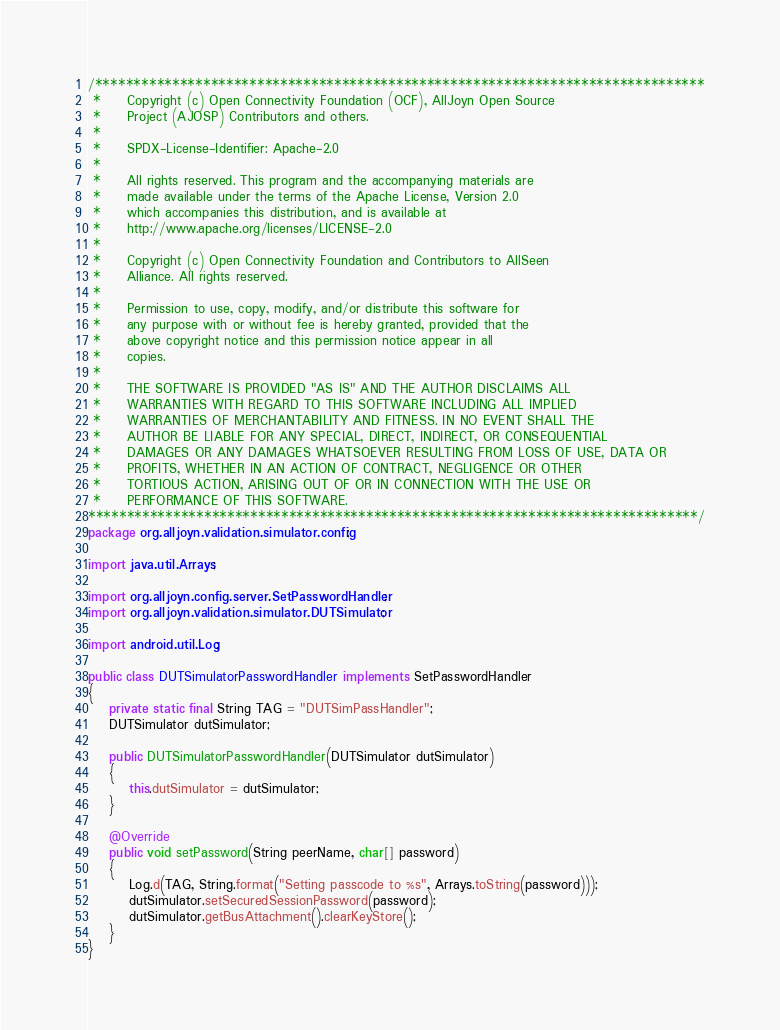Convert code to text. <code><loc_0><loc_0><loc_500><loc_500><_Java_>/*******************************************************************************
 *     Copyright (c) Open Connectivity Foundation (OCF), AllJoyn Open Source
 *     Project (AJOSP) Contributors and others.
 *     
 *     SPDX-License-Identifier: Apache-2.0
 *     
 *     All rights reserved. This program and the accompanying materials are
 *     made available under the terms of the Apache License, Version 2.0
 *     which accompanies this distribution, and is available at
 *     http://www.apache.org/licenses/LICENSE-2.0
 *     
 *     Copyright (c) Open Connectivity Foundation and Contributors to AllSeen
 *     Alliance. All rights reserved.
 *     
 *     Permission to use, copy, modify, and/or distribute this software for
 *     any purpose with or without fee is hereby granted, provided that the
 *     above copyright notice and this permission notice appear in all
 *     copies.
 *     
 *     THE SOFTWARE IS PROVIDED "AS IS" AND THE AUTHOR DISCLAIMS ALL
 *     WARRANTIES WITH REGARD TO THIS SOFTWARE INCLUDING ALL IMPLIED
 *     WARRANTIES OF MERCHANTABILITY AND FITNESS. IN NO EVENT SHALL THE
 *     AUTHOR BE LIABLE FOR ANY SPECIAL, DIRECT, INDIRECT, OR CONSEQUENTIAL
 *     DAMAGES OR ANY DAMAGES WHATSOEVER RESULTING FROM LOSS OF USE, DATA OR
 *     PROFITS, WHETHER IN AN ACTION OF CONTRACT, NEGLIGENCE OR OTHER
 *     TORTIOUS ACTION, ARISING OUT OF OR IN CONNECTION WITH THE USE OR
 *     PERFORMANCE OF THIS SOFTWARE.
*******************************************************************************/
package org.alljoyn.validation.simulator.config;

import java.util.Arrays;

import org.alljoyn.config.server.SetPasswordHandler;
import org.alljoyn.validation.simulator.DUTSimulator;

import android.util.Log;

public class DUTSimulatorPasswordHandler implements SetPasswordHandler
{
    private static final String TAG = "DUTSimPassHandler";
    DUTSimulator dutSimulator;

    public DUTSimulatorPasswordHandler(DUTSimulator dutSimulator)
    {
        this.dutSimulator = dutSimulator;
    }

    @Override
    public void setPassword(String peerName, char[] password)
    {
        Log.d(TAG, String.format("Setting passcode to %s", Arrays.toString(password)));
        dutSimulator.setSecuredSessionPassword(password);
        dutSimulator.getBusAttachment().clearKeyStore();
    }
}</code> 